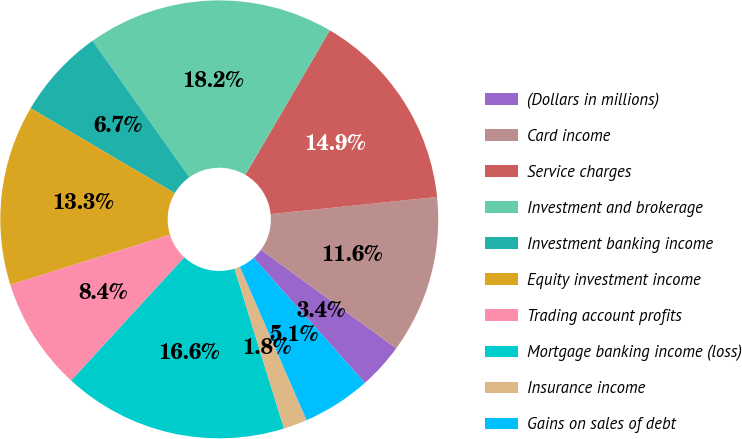Convert chart. <chart><loc_0><loc_0><loc_500><loc_500><pie_chart><fcel>(Dollars in millions)<fcel>Card income<fcel>Service charges<fcel>Investment and brokerage<fcel>Investment banking income<fcel>Equity investment income<fcel>Trading account profits<fcel>Mortgage banking income (loss)<fcel>Insurance income<fcel>Gains on sales of debt<nl><fcel>3.4%<fcel>11.65%<fcel>14.95%<fcel>18.25%<fcel>6.7%<fcel>13.3%<fcel>8.35%<fcel>16.6%<fcel>1.75%<fcel>5.05%<nl></chart> 